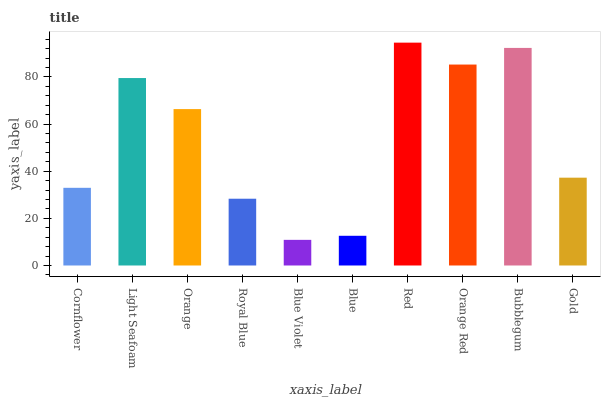Is Blue Violet the minimum?
Answer yes or no. Yes. Is Red the maximum?
Answer yes or no. Yes. Is Light Seafoam the minimum?
Answer yes or no. No. Is Light Seafoam the maximum?
Answer yes or no. No. Is Light Seafoam greater than Cornflower?
Answer yes or no. Yes. Is Cornflower less than Light Seafoam?
Answer yes or no. Yes. Is Cornflower greater than Light Seafoam?
Answer yes or no. No. Is Light Seafoam less than Cornflower?
Answer yes or no. No. Is Orange the high median?
Answer yes or no. Yes. Is Gold the low median?
Answer yes or no. Yes. Is Bubblegum the high median?
Answer yes or no. No. Is Light Seafoam the low median?
Answer yes or no. No. 